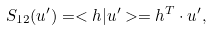Convert formula to latex. <formula><loc_0><loc_0><loc_500><loc_500>S _ { 1 2 } ( u ^ { \prime } ) = < h | u ^ { \prime } > = { h ^ { T } } \cdot u ^ { \prime } ,</formula> 